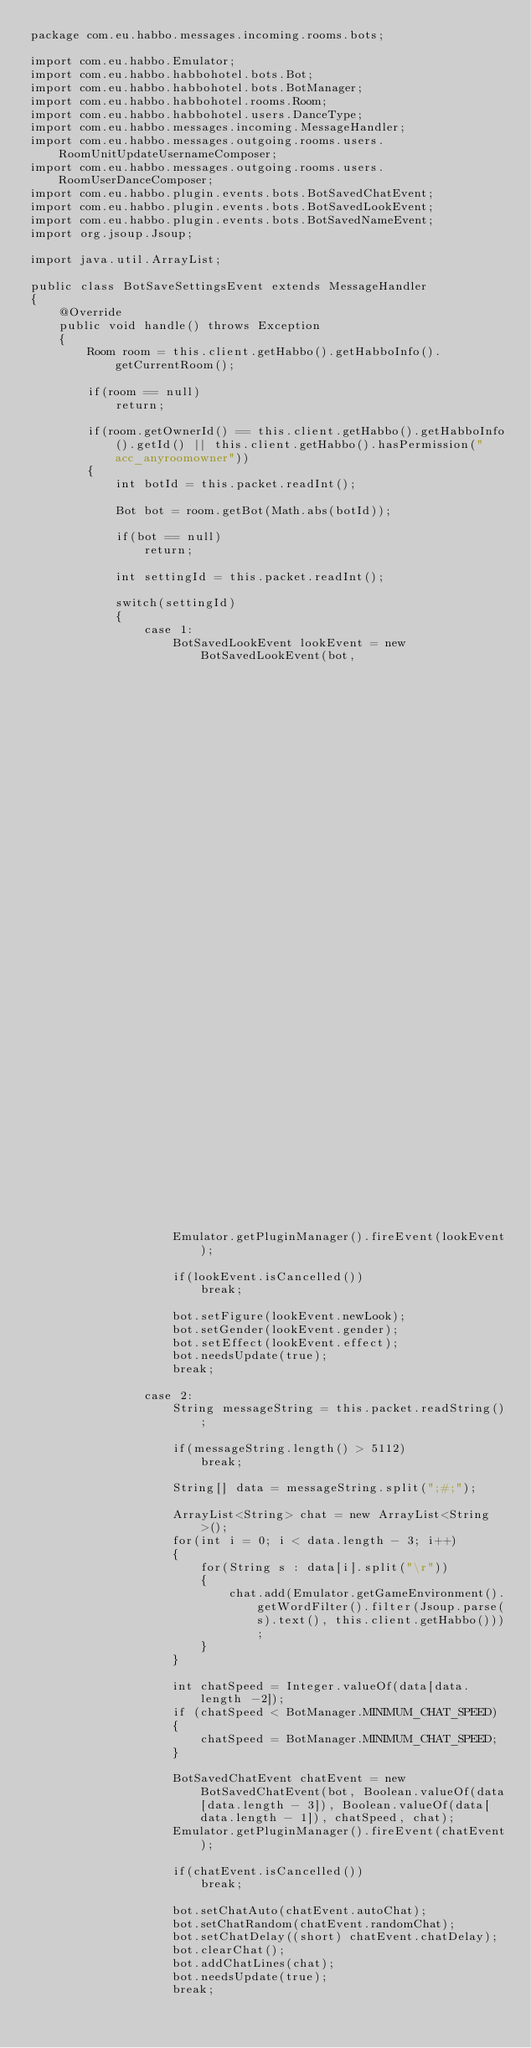<code> <loc_0><loc_0><loc_500><loc_500><_Java_>package com.eu.habbo.messages.incoming.rooms.bots;

import com.eu.habbo.Emulator;
import com.eu.habbo.habbohotel.bots.Bot;
import com.eu.habbo.habbohotel.bots.BotManager;
import com.eu.habbo.habbohotel.rooms.Room;
import com.eu.habbo.habbohotel.users.DanceType;
import com.eu.habbo.messages.incoming.MessageHandler;
import com.eu.habbo.messages.outgoing.rooms.users.RoomUnitUpdateUsernameComposer;
import com.eu.habbo.messages.outgoing.rooms.users.RoomUserDanceComposer;
import com.eu.habbo.plugin.events.bots.BotSavedChatEvent;
import com.eu.habbo.plugin.events.bots.BotSavedLookEvent;
import com.eu.habbo.plugin.events.bots.BotSavedNameEvent;
import org.jsoup.Jsoup;

import java.util.ArrayList;

public class BotSaveSettingsEvent extends MessageHandler
{
    @Override
    public void handle() throws Exception
    {
        Room room = this.client.getHabbo().getHabboInfo().getCurrentRoom();

        if(room == null)
            return;

        if(room.getOwnerId() == this.client.getHabbo().getHabboInfo().getId() || this.client.getHabbo().hasPermission("acc_anyroomowner"))
        {
            int botId = this.packet.readInt();

            Bot bot = room.getBot(Math.abs(botId));

            if(bot == null)
                return;

            int settingId = this.packet.readInt();

            switch(settingId)
            {
                case 1:
                    BotSavedLookEvent lookEvent = new BotSavedLookEvent(bot,
                                                                        this.client.getHabbo().getHabboInfo().getGender(),
                                                                        this.client.getHabbo().getHabboInfo().getLook(),
                                                                        this.client.getHabbo().getRoomUnit().getEffectId());
                    Emulator.getPluginManager().fireEvent(lookEvent);

                    if(lookEvent.isCancelled())
                        break;

                    bot.setFigure(lookEvent.newLook);
                    bot.setGender(lookEvent.gender);
                    bot.setEffect(lookEvent.effect);
                    bot.needsUpdate(true);
                    break;

                case 2:
                    String messageString = this.packet.readString();

                    if(messageString.length() > 5112)
                        break;

                    String[] data = messageString.split(";#;");

                    ArrayList<String> chat = new ArrayList<String>();
                    for(int i = 0; i < data.length - 3; i++)
                    {
                        for(String s : data[i].split("\r"))
                        {
                            chat.add(Emulator.getGameEnvironment().getWordFilter().filter(Jsoup.parse(s).text(), this.client.getHabbo()));
                        }
                    }

                    int chatSpeed = Integer.valueOf(data[data.length -2]);
                    if (chatSpeed < BotManager.MINIMUM_CHAT_SPEED)
                    {
                        chatSpeed = BotManager.MINIMUM_CHAT_SPEED;
                    }

                    BotSavedChatEvent chatEvent = new BotSavedChatEvent(bot, Boolean.valueOf(data[data.length - 3]), Boolean.valueOf(data[data.length - 1]), chatSpeed, chat);
                    Emulator.getPluginManager().fireEvent(chatEvent);

                    if(chatEvent.isCancelled())
                        break;

                    bot.setChatAuto(chatEvent.autoChat);
                    bot.setChatRandom(chatEvent.randomChat);
                    bot.setChatDelay((short) chatEvent.chatDelay);
                    bot.clearChat();
                    bot.addChatLines(chat);
                    bot.needsUpdate(true);
                    break;
</code> 